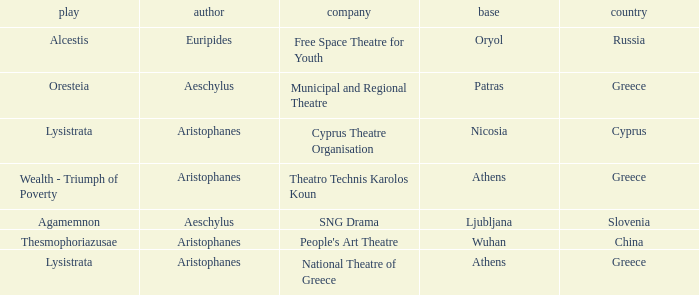What is the play when the company is national theatre of greece? Lysistrata. 